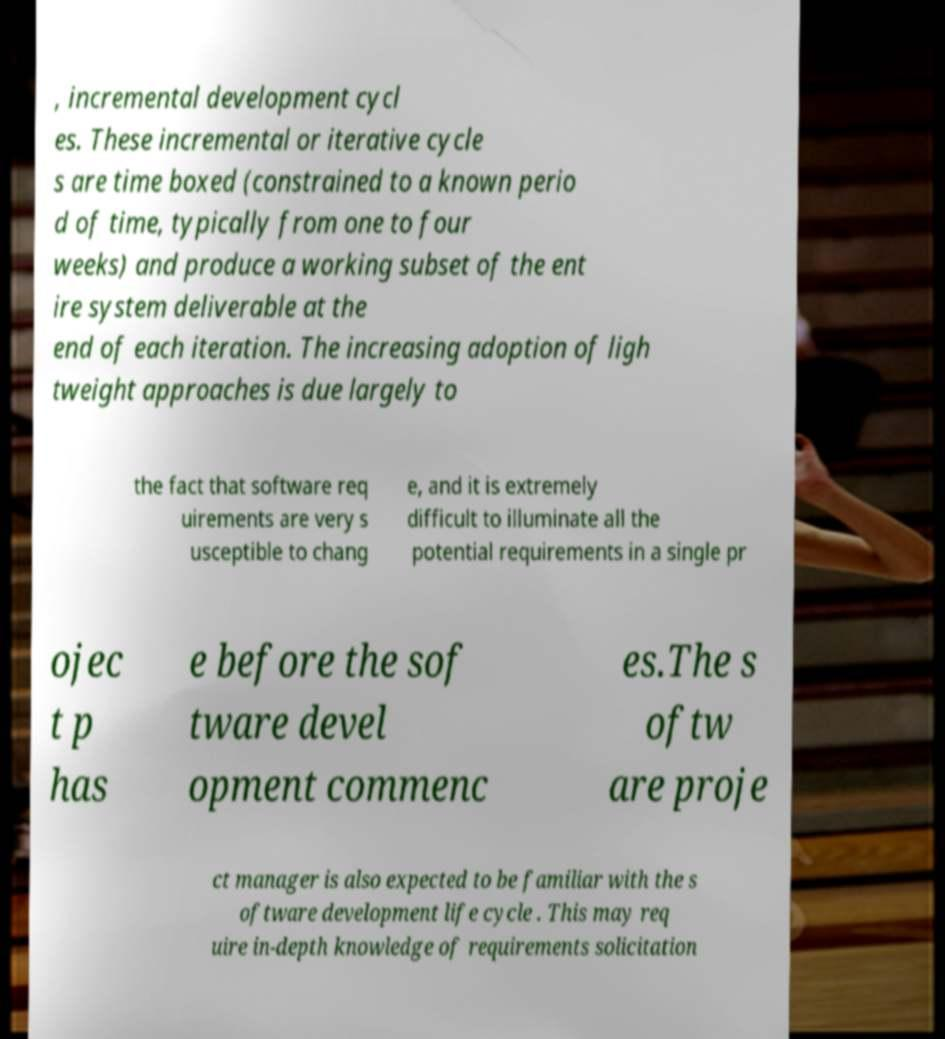I need the written content from this picture converted into text. Can you do that? , incremental development cycl es. These incremental or iterative cycle s are time boxed (constrained to a known perio d of time, typically from one to four weeks) and produce a working subset of the ent ire system deliverable at the end of each iteration. The increasing adoption of ligh tweight approaches is due largely to the fact that software req uirements are very s usceptible to chang e, and it is extremely difficult to illuminate all the potential requirements in a single pr ojec t p has e before the sof tware devel opment commenc es.The s oftw are proje ct manager is also expected to be familiar with the s oftware development life cycle . This may req uire in-depth knowledge of requirements solicitation 